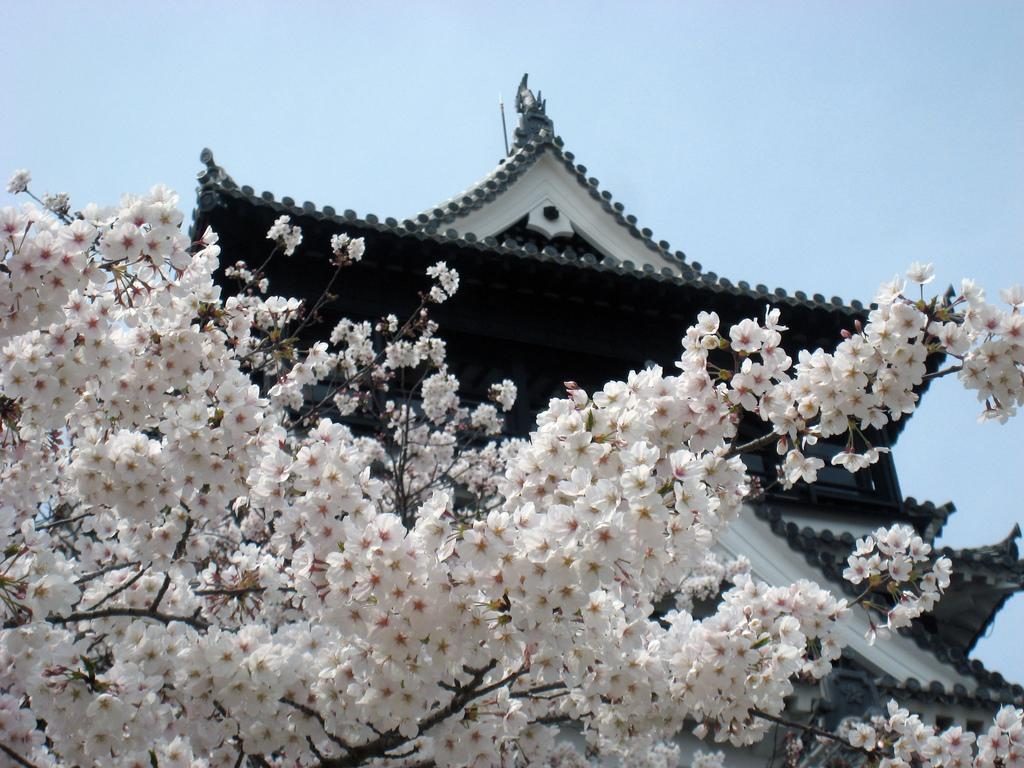What type of plants can be seen in the front of the image? There are flowers in the front of the image. What color are the flowers? The flowers are white in color. What can be seen in the background of the image? There is a building in the background of the image. How many cans of soda are placed next to the flowers in the image? There is no mention of soda cans in the image; it only features flowers and a building in the background. 